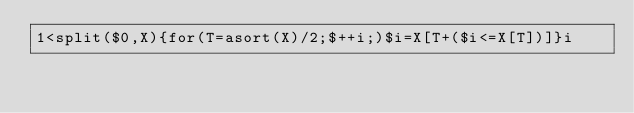<code> <loc_0><loc_0><loc_500><loc_500><_Awk_>1<split($0,X){for(T=asort(X)/2;$++i;)$i=X[T+($i<=X[T])]}i</code> 